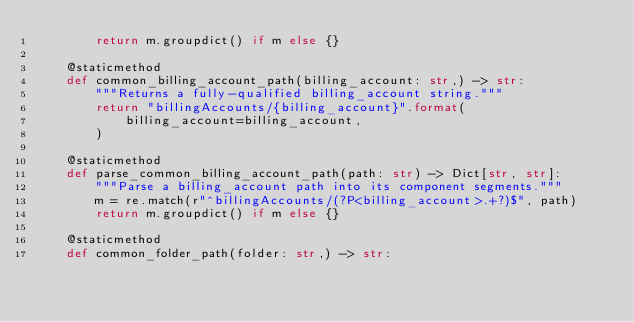Convert code to text. <code><loc_0><loc_0><loc_500><loc_500><_Python_>        return m.groupdict() if m else {}

    @staticmethod
    def common_billing_account_path(billing_account: str,) -> str:
        """Returns a fully-qualified billing_account string."""
        return "billingAccounts/{billing_account}".format(
            billing_account=billing_account,
        )

    @staticmethod
    def parse_common_billing_account_path(path: str) -> Dict[str, str]:
        """Parse a billing_account path into its component segments."""
        m = re.match(r"^billingAccounts/(?P<billing_account>.+?)$", path)
        return m.groupdict() if m else {}

    @staticmethod
    def common_folder_path(folder: str,) -> str:</code> 